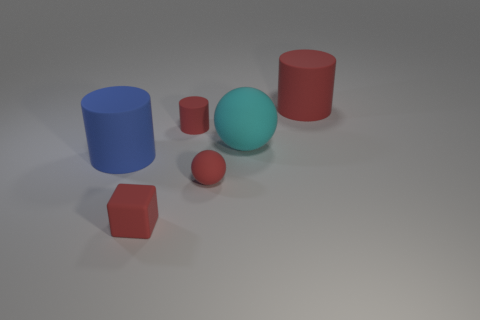Is there a tiny cylinder that has the same material as the tiny red sphere?
Provide a succinct answer. Yes. What is the shape of the small matte thing behind the big matte thing to the left of the ball in front of the blue rubber cylinder?
Make the answer very short. Cylinder. Do the block and the matte cylinder on the right side of the red rubber ball have the same size?
Your answer should be compact. No. There is a object that is both on the left side of the small matte sphere and in front of the big blue matte cylinder; what shape is it?
Your answer should be very brief. Cube. How many big objects are either cyan matte spheres or blue cylinders?
Offer a terse response. 2. Are there the same number of objects that are behind the red rubber ball and tiny red matte cylinders in front of the big blue matte cylinder?
Your answer should be compact. No. How many other things are the same color as the tiny matte cylinder?
Provide a short and direct response. 3. Is the number of large red cylinders that are on the right side of the blue rubber cylinder the same as the number of small rubber cylinders?
Give a very brief answer. Yes. Is the size of the cyan rubber sphere the same as the block?
Offer a very short reply. No. The tiny thing that is both in front of the tiny cylinder and on the right side of the small matte cube is made of what material?
Your response must be concise. Rubber. 